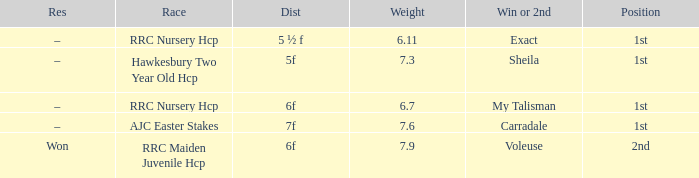What was the race when the winner of 2nd was Voleuse? RRC Maiden Juvenile Hcp. 